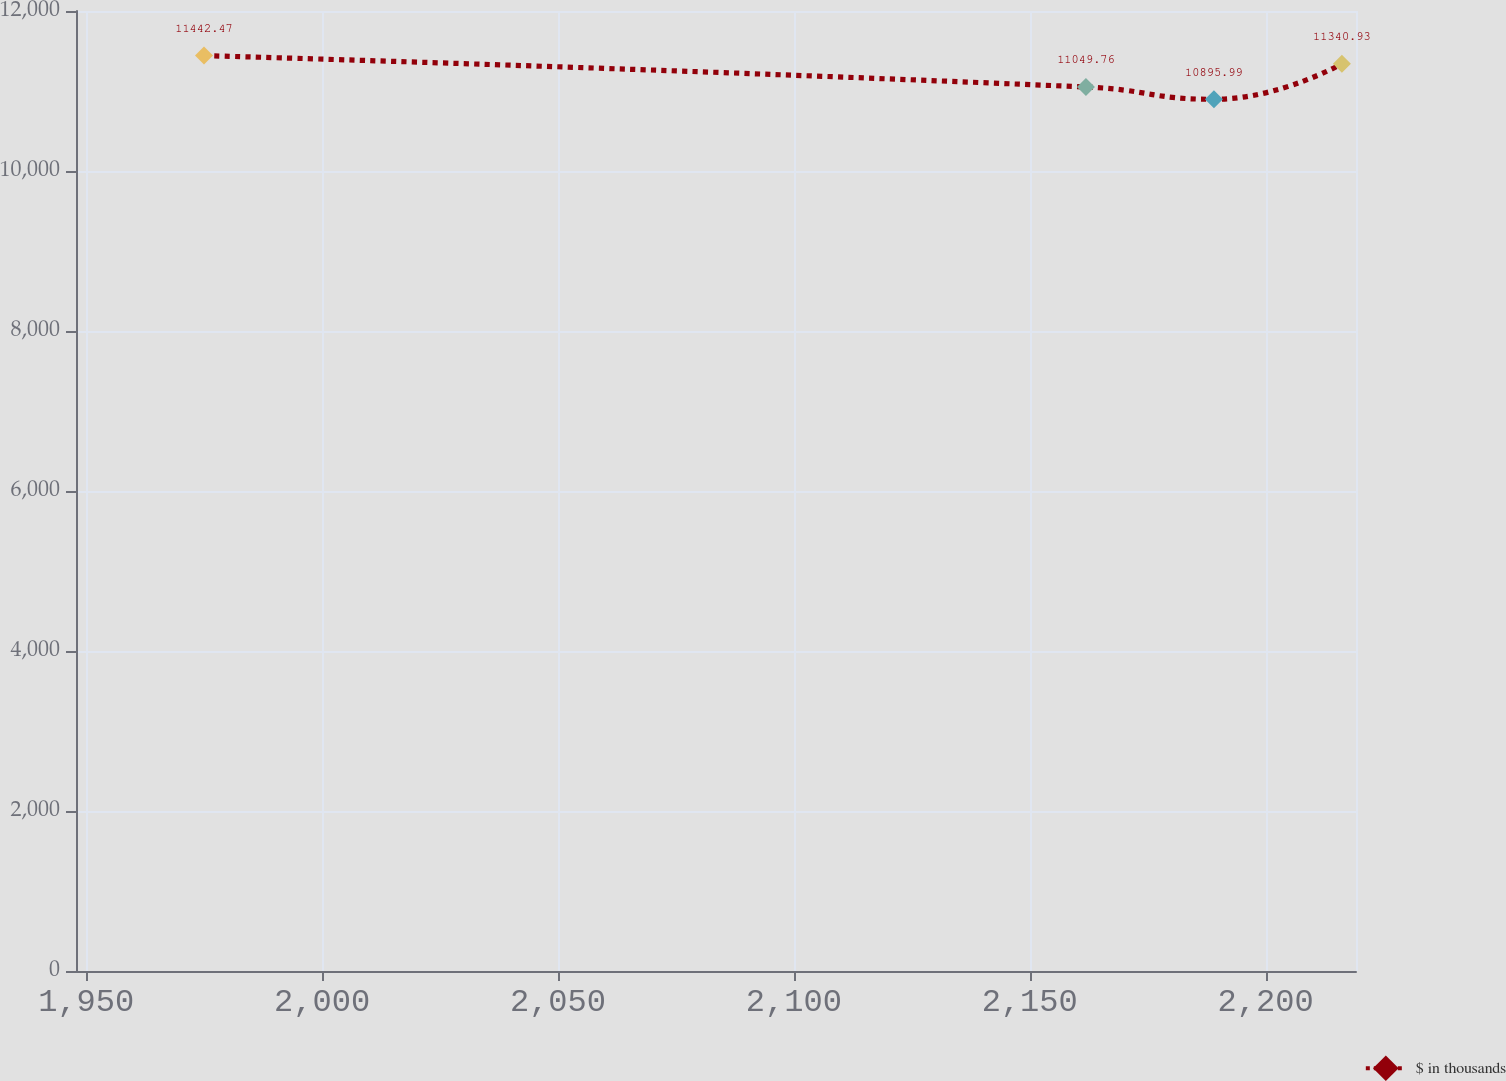Convert chart. <chart><loc_0><loc_0><loc_500><loc_500><line_chart><ecel><fcel>$ in thousands<nl><fcel>1974.97<fcel>11442.5<nl><fcel>2161.92<fcel>11049.8<nl><fcel>2189.05<fcel>10896<nl><fcel>2216.18<fcel>11340.9<nl><fcel>2246.3<fcel>11911.4<nl></chart> 